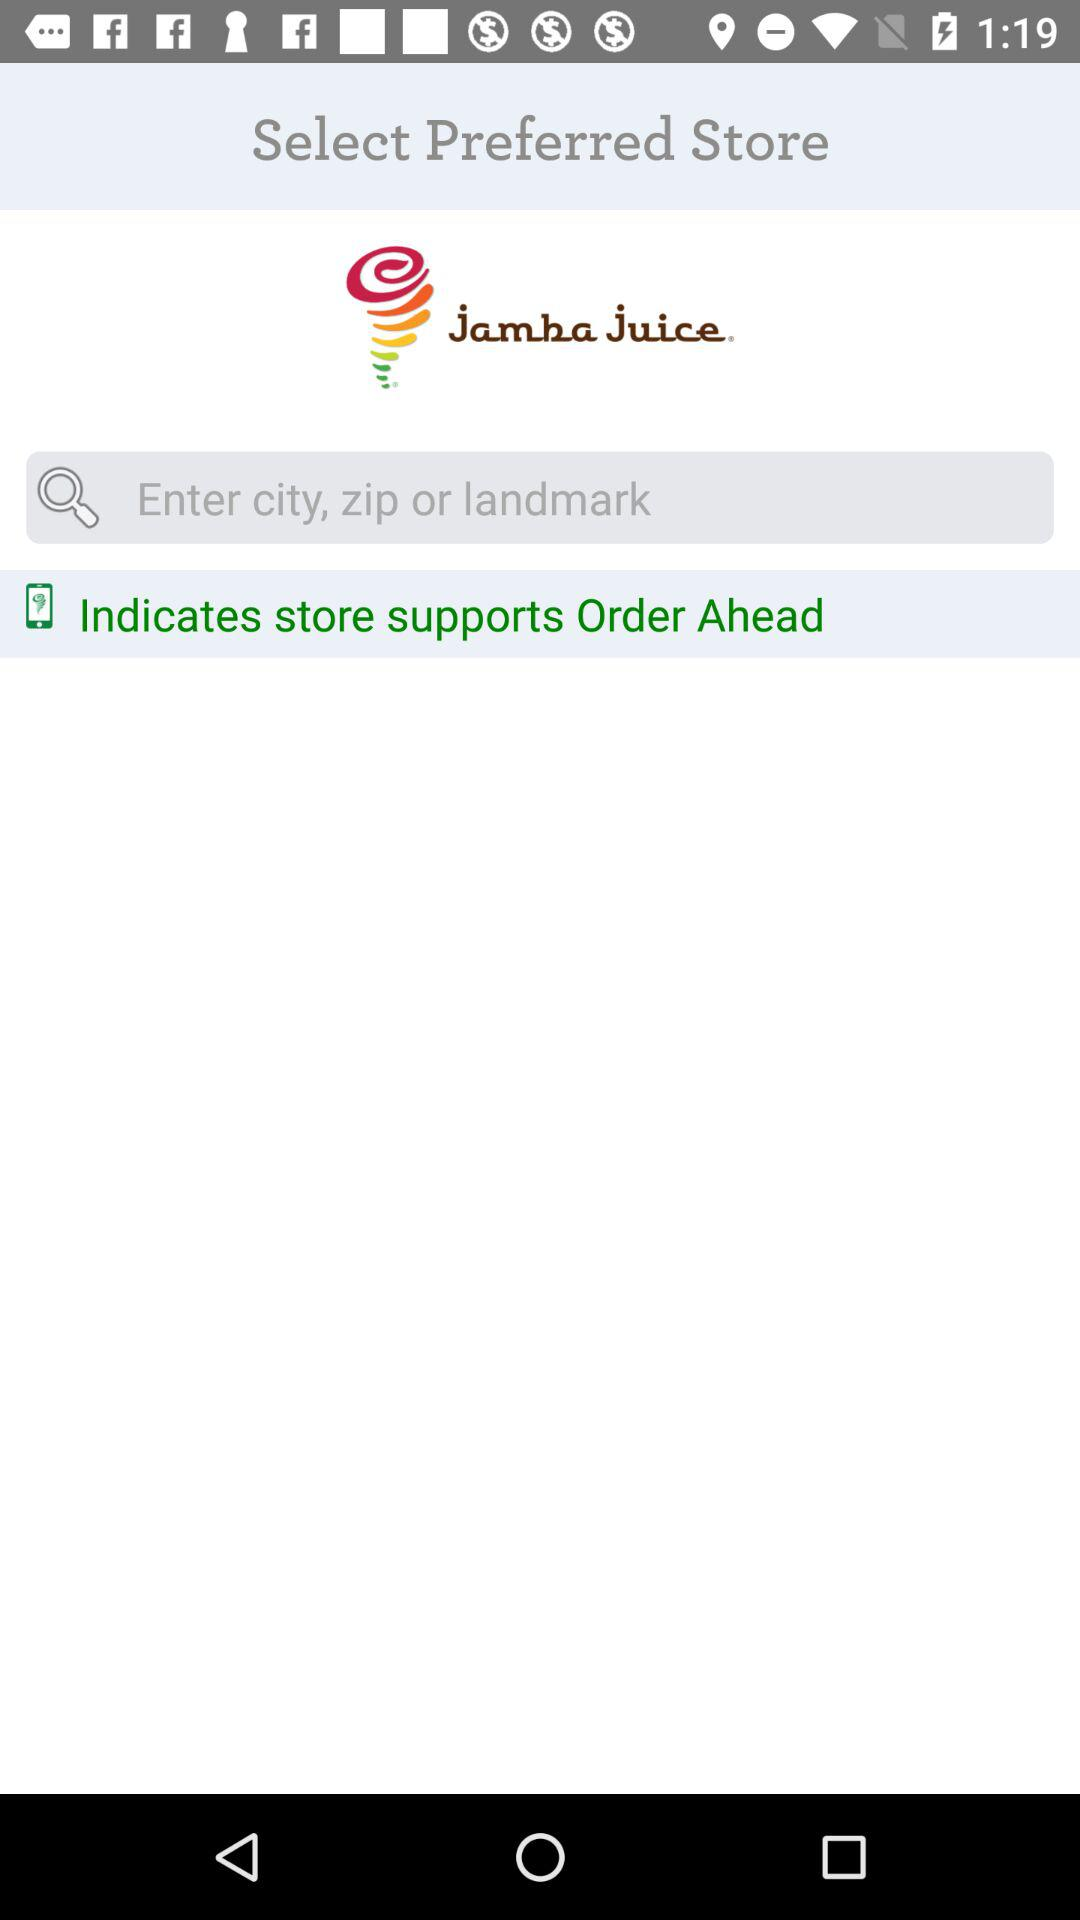How many text inputs are on the screen?
Answer the question using a single word or phrase. 1 